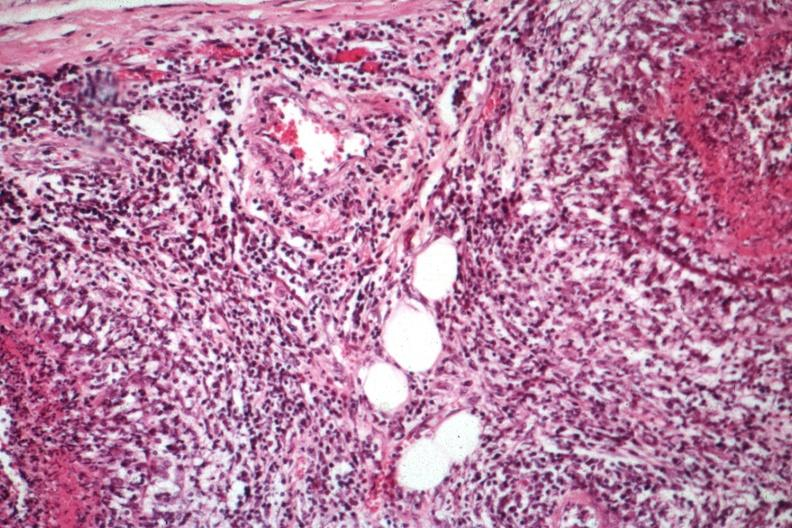s rheumatoid arthritis with vasculitis present?
Answer the question using a single word or phrase. Yes 